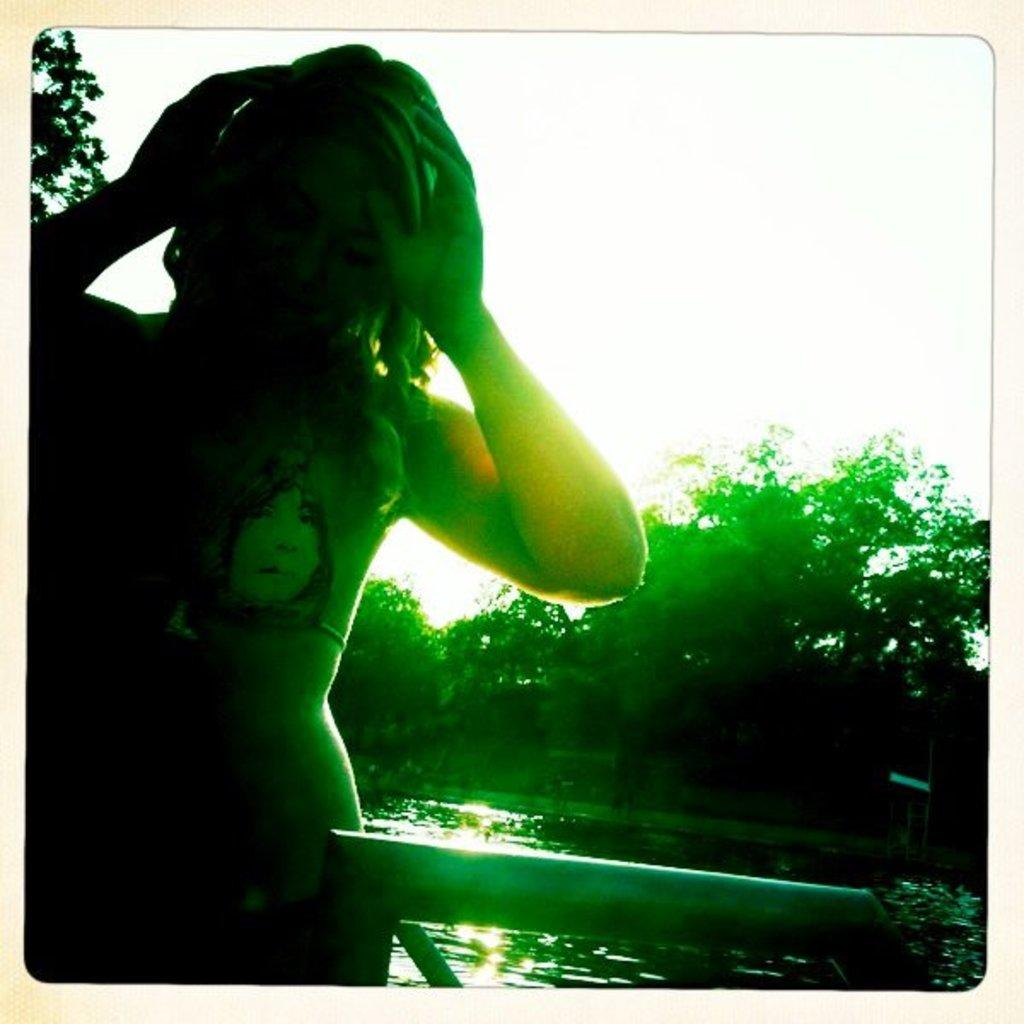Who is the main subject in the image? There is a girl standing in the image. Where is the girl standing? The girl is standing at a pond. What can be seen in the background of the image? There is water, trees, and the sky visible in the background of the image. What type of letters can be seen floating on the water in the image? There are no letters visible in the image, and they are not floating on the water. 